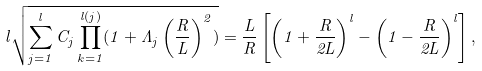Convert formula to latex. <formula><loc_0><loc_0><loc_500><loc_500>l \sqrt { \sum _ { j = 1 } ^ { l } C _ { j } \prod _ { k = 1 } ^ { l ( j ) } ( 1 + \Lambda _ { j } \left ( \frac { R } { L } \right ) ^ { 2 } ) } = \frac { L } { R } \left [ \left ( 1 + \frac { R } { 2 L } \right ) ^ { l } - \left ( 1 - \frac { R } { 2 L } \right ) ^ { l } \right ] ,</formula> 